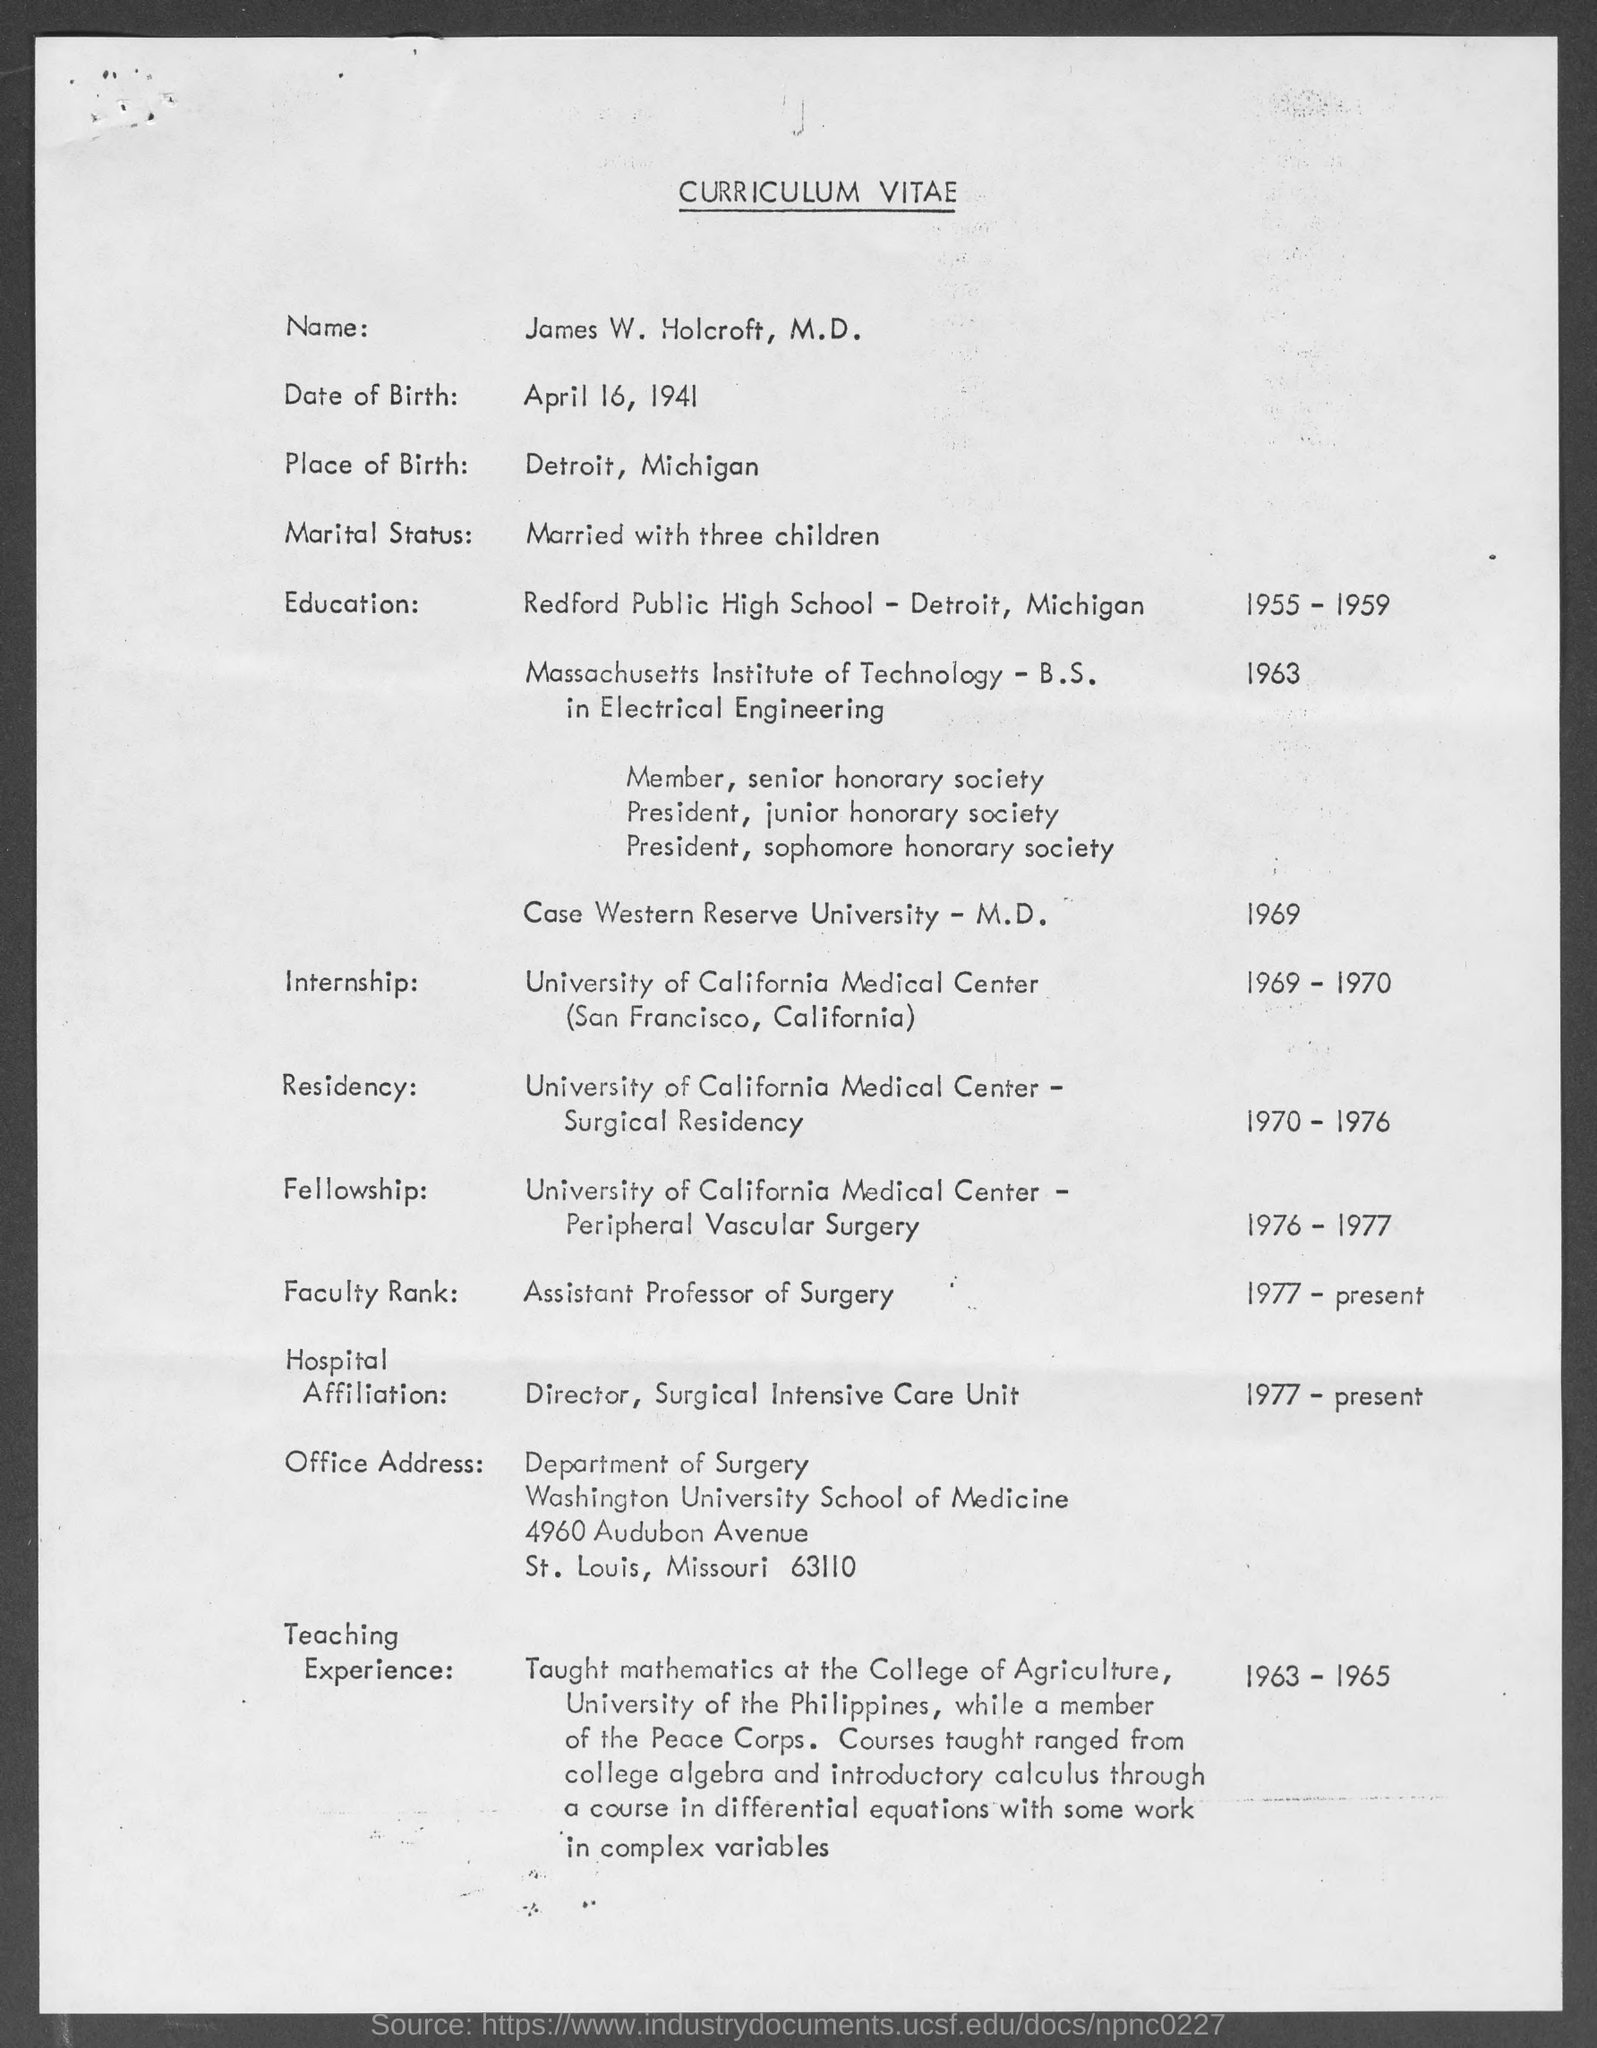Highlight a few significant elements in this photo. Detroit, Michigan is the place of birth. This document is a curriculum vitae. In 1969 and 1970, he completed his internship. 